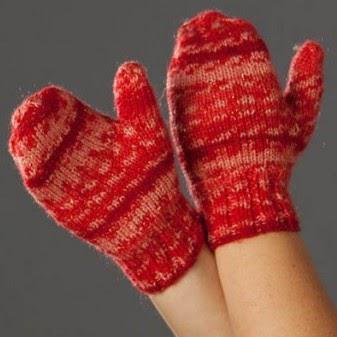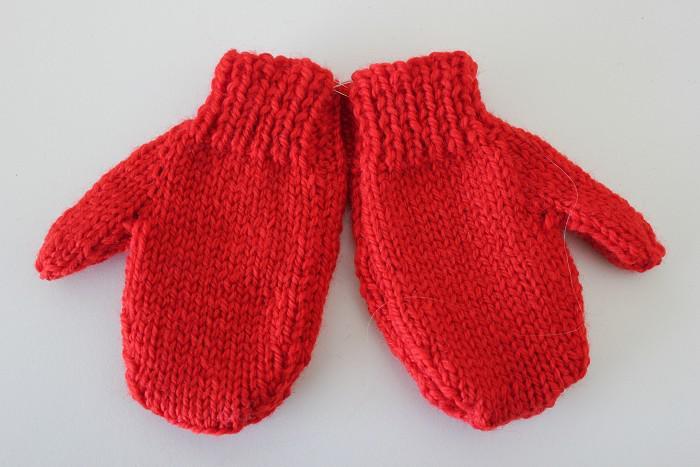The first image is the image on the left, the second image is the image on the right. Considering the images on both sides, is "There is at least one pair of gloves with the both thumb parts pointing right." valid? Answer yes or no. Yes. The first image is the image on the left, the second image is the image on the right. For the images shown, is this caption "Each image contains exactly one mitten pair, and all mittens feature reddish-orange color." true? Answer yes or no. Yes. 